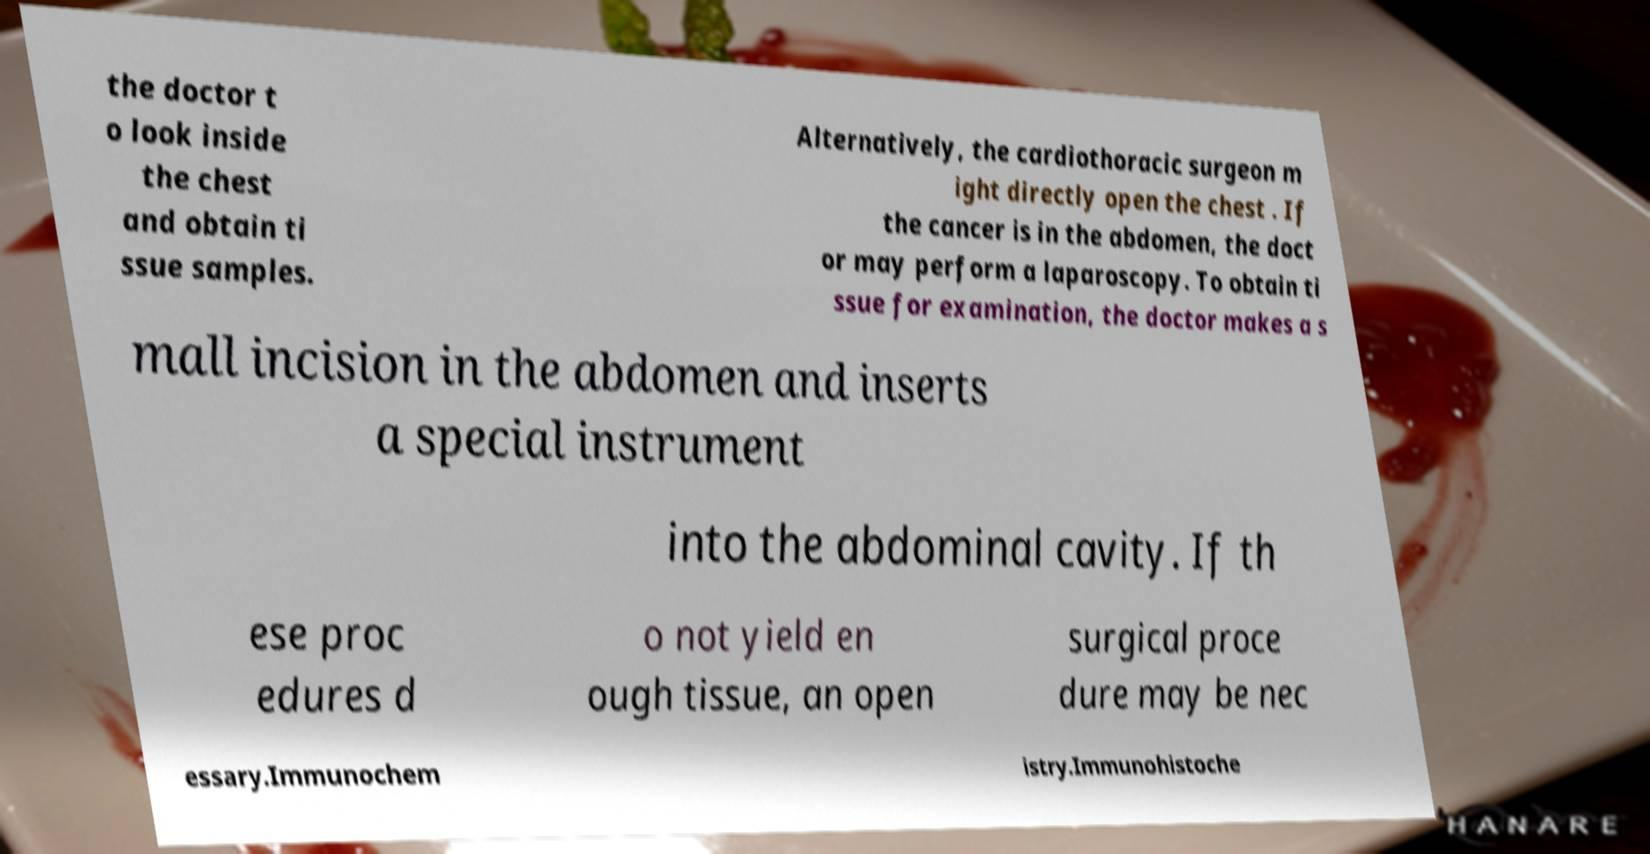Can you accurately transcribe the text from the provided image for me? the doctor t o look inside the chest and obtain ti ssue samples. Alternatively, the cardiothoracic surgeon m ight directly open the chest . If the cancer is in the abdomen, the doct or may perform a laparoscopy. To obtain ti ssue for examination, the doctor makes a s mall incision in the abdomen and inserts a special instrument into the abdominal cavity. If th ese proc edures d o not yield en ough tissue, an open surgical proce dure may be nec essary.Immunochem istry.Immunohistoche 